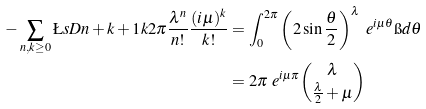<formula> <loc_0><loc_0><loc_500><loc_500>- \sum _ { n , k \geq 0 } \L s D { n + k + 1 } { k } { 2 \pi } \frac { \lambda ^ { n } } { n ! } \frac { ( i \mu ) ^ { k } } { k ! } & = \int _ { 0 } ^ { 2 \pi } \left ( 2 \sin \frac { \theta } { 2 } \right ) ^ { \lambda } \ e ^ { i \mu \theta } \i d \theta \\ & = 2 \pi \ e ^ { i \mu \pi } \binom { \lambda } { \frac { \lambda } { 2 } + \mu }</formula> 